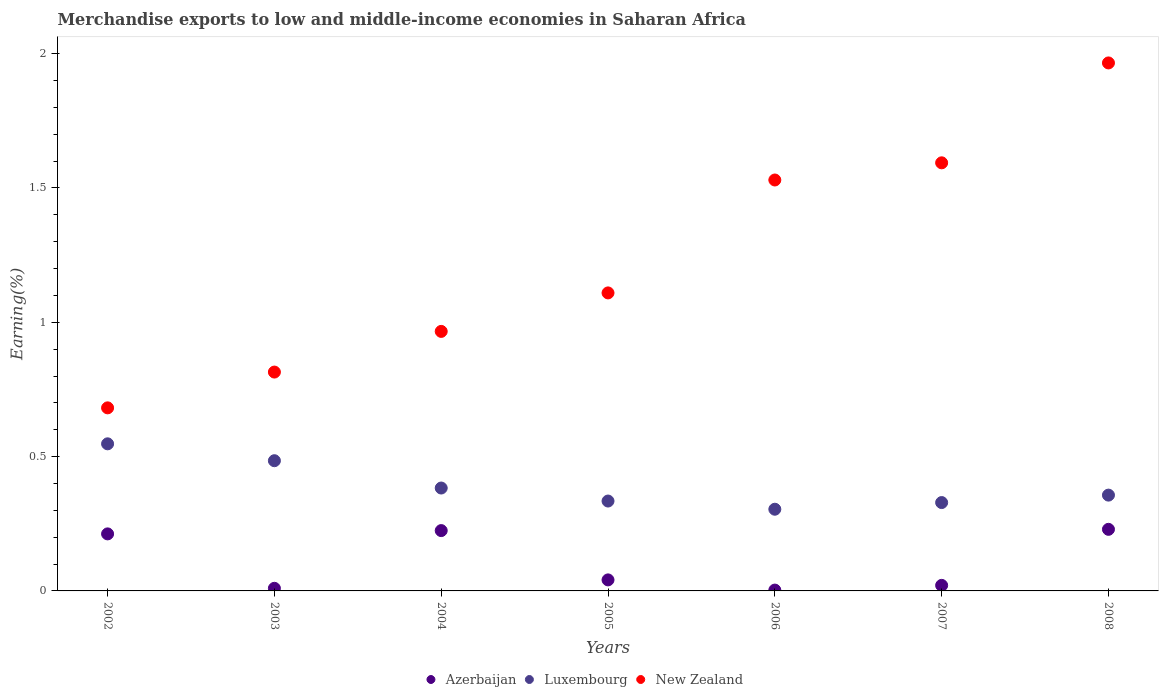How many different coloured dotlines are there?
Provide a succinct answer. 3. Is the number of dotlines equal to the number of legend labels?
Make the answer very short. Yes. What is the percentage of amount earned from merchandise exports in New Zealand in 2008?
Keep it short and to the point. 1.97. Across all years, what is the maximum percentage of amount earned from merchandise exports in New Zealand?
Your answer should be very brief. 1.97. Across all years, what is the minimum percentage of amount earned from merchandise exports in New Zealand?
Offer a terse response. 0.68. In which year was the percentage of amount earned from merchandise exports in Azerbaijan minimum?
Keep it short and to the point. 2006. What is the total percentage of amount earned from merchandise exports in Luxembourg in the graph?
Provide a succinct answer. 2.74. What is the difference between the percentage of amount earned from merchandise exports in New Zealand in 2004 and that in 2007?
Offer a terse response. -0.63. What is the difference between the percentage of amount earned from merchandise exports in Azerbaijan in 2006 and the percentage of amount earned from merchandise exports in New Zealand in 2004?
Your answer should be very brief. -0.96. What is the average percentage of amount earned from merchandise exports in New Zealand per year?
Make the answer very short. 1.24. In the year 2002, what is the difference between the percentage of amount earned from merchandise exports in Luxembourg and percentage of amount earned from merchandise exports in Azerbaijan?
Your response must be concise. 0.34. What is the ratio of the percentage of amount earned from merchandise exports in New Zealand in 2004 to that in 2007?
Your answer should be very brief. 0.61. Is the percentage of amount earned from merchandise exports in Luxembourg in 2004 less than that in 2008?
Provide a short and direct response. No. What is the difference between the highest and the second highest percentage of amount earned from merchandise exports in New Zealand?
Provide a succinct answer. 0.37. What is the difference between the highest and the lowest percentage of amount earned from merchandise exports in Azerbaijan?
Your answer should be very brief. 0.23. Is it the case that in every year, the sum of the percentage of amount earned from merchandise exports in New Zealand and percentage of amount earned from merchandise exports in Luxembourg  is greater than the percentage of amount earned from merchandise exports in Azerbaijan?
Ensure brevity in your answer.  Yes. Is the percentage of amount earned from merchandise exports in New Zealand strictly less than the percentage of amount earned from merchandise exports in Azerbaijan over the years?
Give a very brief answer. No. How many years are there in the graph?
Your answer should be compact. 7. What is the difference between two consecutive major ticks on the Y-axis?
Your response must be concise. 0.5. Are the values on the major ticks of Y-axis written in scientific E-notation?
Ensure brevity in your answer.  No. Where does the legend appear in the graph?
Make the answer very short. Bottom center. How many legend labels are there?
Offer a very short reply. 3. How are the legend labels stacked?
Your answer should be compact. Horizontal. What is the title of the graph?
Your answer should be compact. Merchandise exports to low and middle-income economies in Saharan Africa. What is the label or title of the X-axis?
Your response must be concise. Years. What is the label or title of the Y-axis?
Your answer should be compact. Earning(%). What is the Earning(%) in Azerbaijan in 2002?
Your response must be concise. 0.21. What is the Earning(%) in Luxembourg in 2002?
Your response must be concise. 0.55. What is the Earning(%) of New Zealand in 2002?
Ensure brevity in your answer.  0.68. What is the Earning(%) of Azerbaijan in 2003?
Ensure brevity in your answer.  0.01. What is the Earning(%) of Luxembourg in 2003?
Provide a short and direct response. 0.48. What is the Earning(%) of New Zealand in 2003?
Make the answer very short. 0.81. What is the Earning(%) in Azerbaijan in 2004?
Make the answer very short. 0.22. What is the Earning(%) of Luxembourg in 2004?
Provide a short and direct response. 0.38. What is the Earning(%) of New Zealand in 2004?
Your answer should be compact. 0.97. What is the Earning(%) of Azerbaijan in 2005?
Give a very brief answer. 0.04. What is the Earning(%) in Luxembourg in 2005?
Offer a very short reply. 0.33. What is the Earning(%) of New Zealand in 2005?
Give a very brief answer. 1.11. What is the Earning(%) in Azerbaijan in 2006?
Your answer should be very brief. 0. What is the Earning(%) in Luxembourg in 2006?
Offer a very short reply. 0.3. What is the Earning(%) of New Zealand in 2006?
Your answer should be compact. 1.53. What is the Earning(%) of Azerbaijan in 2007?
Offer a very short reply. 0.02. What is the Earning(%) of Luxembourg in 2007?
Keep it short and to the point. 0.33. What is the Earning(%) of New Zealand in 2007?
Give a very brief answer. 1.59. What is the Earning(%) of Azerbaijan in 2008?
Your answer should be compact. 0.23. What is the Earning(%) in Luxembourg in 2008?
Keep it short and to the point. 0.36. What is the Earning(%) in New Zealand in 2008?
Provide a short and direct response. 1.97. Across all years, what is the maximum Earning(%) of Azerbaijan?
Offer a terse response. 0.23. Across all years, what is the maximum Earning(%) of Luxembourg?
Your answer should be compact. 0.55. Across all years, what is the maximum Earning(%) in New Zealand?
Provide a short and direct response. 1.97. Across all years, what is the minimum Earning(%) in Azerbaijan?
Keep it short and to the point. 0. Across all years, what is the minimum Earning(%) in Luxembourg?
Keep it short and to the point. 0.3. Across all years, what is the minimum Earning(%) in New Zealand?
Give a very brief answer. 0.68. What is the total Earning(%) in Azerbaijan in the graph?
Ensure brevity in your answer.  0.74. What is the total Earning(%) of Luxembourg in the graph?
Your answer should be very brief. 2.74. What is the total Earning(%) of New Zealand in the graph?
Offer a very short reply. 8.66. What is the difference between the Earning(%) in Azerbaijan in 2002 and that in 2003?
Provide a short and direct response. 0.2. What is the difference between the Earning(%) in Luxembourg in 2002 and that in 2003?
Your response must be concise. 0.06. What is the difference between the Earning(%) of New Zealand in 2002 and that in 2003?
Provide a short and direct response. -0.13. What is the difference between the Earning(%) of Azerbaijan in 2002 and that in 2004?
Your response must be concise. -0.01. What is the difference between the Earning(%) of Luxembourg in 2002 and that in 2004?
Your response must be concise. 0.16. What is the difference between the Earning(%) in New Zealand in 2002 and that in 2004?
Your response must be concise. -0.28. What is the difference between the Earning(%) in Azerbaijan in 2002 and that in 2005?
Provide a short and direct response. 0.17. What is the difference between the Earning(%) in Luxembourg in 2002 and that in 2005?
Your response must be concise. 0.21. What is the difference between the Earning(%) in New Zealand in 2002 and that in 2005?
Ensure brevity in your answer.  -0.43. What is the difference between the Earning(%) of Azerbaijan in 2002 and that in 2006?
Provide a short and direct response. 0.21. What is the difference between the Earning(%) in Luxembourg in 2002 and that in 2006?
Your answer should be very brief. 0.24. What is the difference between the Earning(%) in New Zealand in 2002 and that in 2006?
Make the answer very short. -0.85. What is the difference between the Earning(%) of Azerbaijan in 2002 and that in 2007?
Keep it short and to the point. 0.19. What is the difference between the Earning(%) in Luxembourg in 2002 and that in 2007?
Your response must be concise. 0.22. What is the difference between the Earning(%) of New Zealand in 2002 and that in 2007?
Provide a short and direct response. -0.91. What is the difference between the Earning(%) in Azerbaijan in 2002 and that in 2008?
Offer a very short reply. -0.02. What is the difference between the Earning(%) of Luxembourg in 2002 and that in 2008?
Offer a terse response. 0.19. What is the difference between the Earning(%) of New Zealand in 2002 and that in 2008?
Your answer should be compact. -1.28. What is the difference between the Earning(%) of Azerbaijan in 2003 and that in 2004?
Your answer should be very brief. -0.21. What is the difference between the Earning(%) of Luxembourg in 2003 and that in 2004?
Your response must be concise. 0.1. What is the difference between the Earning(%) in New Zealand in 2003 and that in 2004?
Your answer should be compact. -0.15. What is the difference between the Earning(%) of Azerbaijan in 2003 and that in 2005?
Your response must be concise. -0.03. What is the difference between the Earning(%) in Luxembourg in 2003 and that in 2005?
Provide a short and direct response. 0.15. What is the difference between the Earning(%) in New Zealand in 2003 and that in 2005?
Your answer should be very brief. -0.29. What is the difference between the Earning(%) of Azerbaijan in 2003 and that in 2006?
Offer a terse response. 0.01. What is the difference between the Earning(%) in Luxembourg in 2003 and that in 2006?
Ensure brevity in your answer.  0.18. What is the difference between the Earning(%) of New Zealand in 2003 and that in 2006?
Provide a succinct answer. -0.71. What is the difference between the Earning(%) of Azerbaijan in 2003 and that in 2007?
Ensure brevity in your answer.  -0.01. What is the difference between the Earning(%) of Luxembourg in 2003 and that in 2007?
Offer a very short reply. 0.16. What is the difference between the Earning(%) in New Zealand in 2003 and that in 2007?
Make the answer very short. -0.78. What is the difference between the Earning(%) of Azerbaijan in 2003 and that in 2008?
Provide a succinct answer. -0.22. What is the difference between the Earning(%) in Luxembourg in 2003 and that in 2008?
Provide a short and direct response. 0.13. What is the difference between the Earning(%) of New Zealand in 2003 and that in 2008?
Provide a succinct answer. -1.15. What is the difference between the Earning(%) in Azerbaijan in 2004 and that in 2005?
Give a very brief answer. 0.18. What is the difference between the Earning(%) in Luxembourg in 2004 and that in 2005?
Offer a terse response. 0.05. What is the difference between the Earning(%) of New Zealand in 2004 and that in 2005?
Ensure brevity in your answer.  -0.14. What is the difference between the Earning(%) in Azerbaijan in 2004 and that in 2006?
Ensure brevity in your answer.  0.22. What is the difference between the Earning(%) in Luxembourg in 2004 and that in 2006?
Your response must be concise. 0.08. What is the difference between the Earning(%) of New Zealand in 2004 and that in 2006?
Give a very brief answer. -0.56. What is the difference between the Earning(%) of Azerbaijan in 2004 and that in 2007?
Your response must be concise. 0.2. What is the difference between the Earning(%) in Luxembourg in 2004 and that in 2007?
Provide a succinct answer. 0.05. What is the difference between the Earning(%) of New Zealand in 2004 and that in 2007?
Provide a short and direct response. -0.63. What is the difference between the Earning(%) in Azerbaijan in 2004 and that in 2008?
Make the answer very short. -0. What is the difference between the Earning(%) in Luxembourg in 2004 and that in 2008?
Your answer should be compact. 0.03. What is the difference between the Earning(%) in New Zealand in 2004 and that in 2008?
Provide a short and direct response. -1. What is the difference between the Earning(%) of Azerbaijan in 2005 and that in 2006?
Ensure brevity in your answer.  0.04. What is the difference between the Earning(%) in Luxembourg in 2005 and that in 2006?
Keep it short and to the point. 0.03. What is the difference between the Earning(%) in New Zealand in 2005 and that in 2006?
Provide a short and direct response. -0.42. What is the difference between the Earning(%) in Azerbaijan in 2005 and that in 2007?
Offer a very short reply. 0.02. What is the difference between the Earning(%) of Luxembourg in 2005 and that in 2007?
Provide a succinct answer. 0.01. What is the difference between the Earning(%) in New Zealand in 2005 and that in 2007?
Your response must be concise. -0.48. What is the difference between the Earning(%) in Azerbaijan in 2005 and that in 2008?
Provide a succinct answer. -0.19. What is the difference between the Earning(%) of Luxembourg in 2005 and that in 2008?
Your answer should be very brief. -0.02. What is the difference between the Earning(%) in New Zealand in 2005 and that in 2008?
Provide a succinct answer. -0.86. What is the difference between the Earning(%) of Azerbaijan in 2006 and that in 2007?
Provide a succinct answer. -0.02. What is the difference between the Earning(%) of Luxembourg in 2006 and that in 2007?
Ensure brevity in your answer.  -0.02. What is the difference between the Earning(%) in New Zealand in 2006 and that in 2007?
Ensure brevity in your answer.  -0.06. What is the difference between the Earning(%) in Azerbaijan in 2006 and that in 2008?
Keep it short and to the point. -0.23. What is the difference between the Earning(%) in Luxembourg in 2006 and that in 2008?
Keep it short and to the point. -0.05. What is the difference between the Earning(%) in New Zealand in 2006 and that in 2008?
Make the answer very short. -0.44. What is the difference between the Earning(%) in Azerbaijan in 2007 and that in 2008?
Your answer should be very brief. -0.21. What is the difference between the Earning(%) in Luxembourg in 2007 and that in 2008?
Provide a succinct answer. -0.03. What is the difference between the Earning(%) in New Zealand in 2007 and that in 2008?
Your answer should be very brief. -0.37. What is the difference between the Earning(%) of Azerbaijan in 2002 and the Earning(%) of Luxembourg in 2003?
Make the answer very short. -0.27. What is the difference between the Earning(%) of Azerbaijan in 2002 and the Earning(%) of New Zealand in 2003?
Make the answer very short. -0.6. What is the difference between the Earning(%) of Luxembourg in 2002 and the Earning(%) of New Zealand in 2003?
Ensure brevity in your answer.  -0.27. What is the difference between the Earning(%) of Azerbaijan in 2002 and the Earning(%) of Luxembourg in 2004?
Provide a short and direct response. -0.17. What is the difference between the Earning(%) in Azerbaijan in 2002 and the Earning(%) in New Zealand in 2004?
Ensure brevity in your answer.  -0.75. What is the difference between the Earning(%) in Luxembourg in 2002 and the Earning(%) in New Zealand in 2004?
Provide a short and direct response. -0.42. What is the difference between the Earning(%) in Azerbaijan in 2002 and the Earning(%) in Luxembourg in 2005?
Keep it short and to the point. -0.12. What is the difference between the Earning(%) in Azerbaijan in 2002 and the Earning(%) in New Zealand in 2005?
Provide a succinct answer. -0.9. What is the difference between the Earning(%) in Luxembourg in 2002 and the Earning(%) in New Zealand in 2005?
Offer a very short reply. -0.56. What is the difference between the Earning(%) of Azerbaijan in 2002 and the Earning(%) of Luxembourg in 2006?
Offer a terse response. -0.09. What is the difference between the Earning(%) in Azerbaijan in 2002 and the Earning(%) in New Zealand in 2006?
Offer a terse response. -1.32. What is the difference between the Earning(%) in Luxembourg in 2002 and the Earning(%) in New Zealand in 2006?
Ensure brevity in your answer.  -0.98. What is the difference between the Earning(%) of Azerbaijan in 2002 and the Earning(%) of Luxembourg in 2007?
Offer a terse response. -0.12. What is the difference between the Earning(%) in Azerbaijan in 2002 and the Earning(%) in New Zealand in 2007?
Keep it short and to the point. -1.38. What is the difference between the Earning(%) of Luxembourg in 2002 and the Earning(%) of New Zealand in 2007?
Provide a succinct answer. -1.05. What is the difference between the Earning(%) of Azerbaijan in 2002 and the Earning(%) of Luxembourg in 2008?
Ensure brevity in your answer.  -0.14. What is the difference between the Earning(%) in Azerbaijan in 2002 and the Earning(%) in New Zealand in 2008?
Provide a short and direct response. -1.75. What is the difference between the Earning(%) in Luxembourg in 2002 and the Earning(%) in New Zealand in 2008?
Ensure brevity in your answer.  -1.42. What is the difference between the Earning(%) of Azerbaijan in 2003 and the Earning(%) of Luxembourg in 2004?
Provide a short and direct response. -0.37. What is the difference between the Earning(%) of Azerbaijan in 2003 and the Earning(%) of New Zealand in 2004?
Provide a short and direct response. -0.96. What is the difference between the Earning(%) of Luxembourg in 2003 and the Earning(%) of New Zealand in 2004?
Provide a succinct answer. -0.48. What is the difference between the Earning(%) of Azerbaijan in 2003 and the Earning(%) of Luxembourg in 2005?
Offer a terse response. -0.32. What is the difference between the Earning(%) of Azerbaijan in 2003 and the Earning(%) of New Zealand in 2005?
Ensure brevity in your answer.  -1.1. What is the difference between the Earning(%) in Luxembourg in 2003 and the Earning(%) in New Zealand in 2005?
Provide a succinct answer. -0.62. What is the difference between the Earning(%) in Azerbaijan in 2003 and the Earning(%) in Luxembourg in 2006?
Your answer should be very brief. -0.29. What is the difference between the Earning(%) in Azerbaijan in 2003 and the Earning(%) in New Zealand in 2006?
Your answer should be very brief. -1.52. What is the difference between the Earning(%) of Luxembourg in 2003 and the Earning(%) of New Zealand in 2006?
Offer a terse response. -1.04. What is the difference between the Earning(%) of Azerbaijan in 2003 and the Earning(%) of Luxembourg in 2007?
Offer a very short reply. -0.32. What is the difference between the Earning(%) in Azerbaijan in 2003 and the Earning(%) in New Zealand in 2007?
Your response must be concise. -1.58. What is the difference between the Earning(%) in Luxembourg in 2003 and the Earning(%) in New Zealand in 2007?
Make the answer very short. -1.11. What is the difference between the Earning(%) in Azerbaijan in 2003 and the Earning(%) in Luxembourg in 2008?
Ensure brevity in your answer.  -0.35. What is the difference between the Earning(%) of Azerbaijan in 2003 and the Earning(%) of New Zealand in 2008?
Offer a very short reply. -1.96. What is the difference between the Earning(%) of Luxembourg in 2003 and the Earning(%) of New Zealand in 2008?
Offer a very short reply. -1.48. What is the difference between the Earning(%) in Azerbaijan in 2004 and the Earning(%) in Luxembourg in 2005?
Your response must be concise. -0.11. What is the difference between the Earning(%) in Azerbaijan in 2004 and the Earning(%) in New Zealand in 2005?
Ensure brevity in your answer.  -0.88. What is the difference between the Earning(%) in Luxembourg in 2004 and the Earning(%) in New Zealand in 2005?
Your answer should be very brief. -0.73. What is the difference between the Earning(%) of Azerbaijan in 2004 and the Earning(%) of Luxembourg in 2006?
Ensure brevity in your answer.  -0.08. What is the difference between the Earning(%) in Azerbaijan in 2004 and the Earning(%) in New Zealand in 2006?
Offer a very short reply. -1.31. What is the difference between the Earning(%) of Luxembourg in 2004 and the Earning(%) of New Zealand in 2006?
Your answer should be very brief. -1.15. What is the difference between the Earning(%) in Azerbaijan in 2004 and the Earning(%) in Luxembourg in 2007?
Your response must be concise. -0.1. What is the difference between the Earning(%) of Azerbaijan in 2004 and the Earning(%) of New Zealand in 2007?
Your answer should be compact. -1.37. What is the difference between the Earning(%) in Luxembourg in 2004 and the Earning(%) in New Zealand in 2007?
Make the answer very short. -1.21. What is the difference between the Earning(%) of Azerbaijan in 2004 and the Earning(%) of Luxembourg in 2008?
Provide a succinct answer. -0.13. What is the difference between the Earning(%) in Azerbaijan in 2004 and the Earning(%) in New Zealand in 2008?
Your response must be concise. -1.74. What is the difference between the Earning(%) of Luxembourg in 2004 and the Earning(%) of New Zealand in 2008?
Offer a very short reply. -1.58. What is the difference between the Earning(%) in Azerbaijan in 2005 and the Earning(%) in Luxembourg in 2006?
Make the answer very short. -0.26. What is the difference between the Earning(%) in Azerbaijan in 2005 and the Earning(%) in New Zealand in 2006?
Make the answer very short. -1.49. What is the difference between the Earning(%) of Luxembourg in 2005 and the Earning(%) of New Zealand in 2006?
Provide a succinct answer. -1.2. What is the difference between the Earning(%) in Azerbaijan in 2005 and the Earning(%) in Luxembourg in 2007?
Offer a very short reply. -0.29. What is the difference between the Earning(%) of Azerbaijan in 2005 and the Earning(%) of New Zealand in 2007?
Offer a very short reply. -1.55. What is the difference between the Earning(%) of Luxembourg in 2005 and the Earning(%) of New Zealand in 2007?
Your answer should be very brief. -1.26. What is the difference between the Earning(%) of Azerbaijan in 2005 and the Earning(%) of Luxembourg in 2008?
Provide a short and direct response. -0.32. What is the difference between the Earning(%) of Azerbaijan in 2005 and the Earning(%) of New Zealand in 2008?
Make the answer very short. -1.92. What is the difference between the Earning(%) in Luxembourg in 2005 and the Earning(%) in New Zealand in 2008?
Keep it short and to the point. -1.63. What is the difference between the Earning(%) in Azerbaijan in 2006 and the Earning(%) in Luxembourg in 2007?
Your answer should be very brief. -0.33. What is the difference between the Earning(%) in Azerbaijan in 2006 and the Earning(%) in New Zealand in 2007?
Make the answer very short. -1.59. What is the difference between the Earning(%) of Luxembourg in 2006 and the Earning(%) of New Zealand in 2007?
Offer a very short reply. -1.29. What is the difference between the Earning(%) of Azerbaijan in 2006 and the Earning(%) of Luxembourg in 2008?
Ensure brevity in your answer.  -0.35. What is the difference between the Earning(%) in Azerbaijan in 2006 and the Earning(%) in New Zealand in 2008?
Your response must be concise. -1.96. What is the difference between the Earning(%) in Luxembourg in 2006 and the Earning(%) in New Zealand in 2008?
Offer a terse response. -1.66. What is the difference between the Earning(%) in Azerbaijan in 2007 and the Earning(%) in Luxembourg in 2008?
Ensure brevity in your answer.  -0.34. What is the difference between the Earning(%) of Azerbaijan in 2007 and the Earning(%) of New Zealand in 2008?
Give a very brief answer. -1.94. What is the difference between the Earning(%) in Luxembourg in 2007 and the Earning(%) in New Zealand in 2008?
Keep it short and to the point. -1.64. What is the average Earning(%) of Azerbaijan per year?
Your answer should be compact. 0.11. What is the average Earning(%) of Luxembourg per year?
Offer a terse response. 0.39. What is the average Earning(%) of New Zealand per year?
Offer a very short reply. 1.24. In the year 2002, what is the difference between the Earning(%) in Azerbaijan and Earning(%) in Luxembourg?
Keep it short and to the point. -0.34. In the year 2002, what is the difference between the Earning(%) of Azerbaijan and Earning(%) of New Zealand?
Your answer should be very brief. -0.47. In the year 2002, what is the difference between the Earning(%) of Luxembourg and Earning(%) of New Zealand?
Offer a terse response. -0.13. In the year 2003, what is the difference between the Earning(%) in Azerbaijan and Earning(%) in Luxembourg?
Your response must be concise. -0.47. In the year 2003, what is the difference between the Earning(%) of Azerbaijan and Earning(%) of New Zealand?
Your response must be concise. -0.81. In the year 2003, what is the difference between the Earning(%) of Luxembourg and Earning(%) of New Zealand?
Your answer should be very brief. -0.33. In the year 2004, what is the difference between the Earning(%) in Azerbaijan and Earning(%) in Luxembourg?
Your response must be concise. -0.16. In the year 2004, what is the difference between the Earning(%) in Azerbaijan and Earning(%) in New Zealand?
Ensure brevity in your answer.  -0.74. In the year 2004, what is the difference between the Earning(%) of Luxembourg and Earning(%) of New Zealand?
Your answer should be very brief. -0.58. In the year 2005, what is the difference between the Earning(%) of Azerbaijan and Earning(%) of Luxembourg?
Offer a terse response. -0.29. In the year 2005, what is the difference between the Earning(%) of Azerbaijan and Earning(%) of New Zealand?
Make the answer very short. -1.07. In the year 2005, what is the difference between the Earning(%) in Luxembourg and Earning(%) in New Zealand?
Offer a very short reply. -0.77. In the year 2006, what is the difference between the Earning(%) in Azerbaijan and Earning(%) in Luxembourg?
Your answer should be very brief. -0.3. In the year 2006, what is the difference between the Earning(%) in Azerbaijan and Earning(%) in New Zealand?
Offer a terse response. -1.53. In the year 2006, what is the difference between the Earning(%) in Luxembourg and Earning(%) in New Zealand?
Ensure brevity in your answer.  -1.23. In the year 2007, what is the difference between the Earning(%) of Azerbaijan and Earning(%) of Luxembourg?
Give a very brief answer. -0.31. In the year 2007, what is the difference between the Earning(%) of Azerbaijan and Earning(%) of New Zealand?
Your response must be concise. -1.57. In the year 2007, what is the difference between the Earning(%) of Luxembourg and Earning(%) of New Zealand?
Your response must be concise. -1.26. In the year 2008, what is the difference between the Earning(%) in Azerbaijan and Earning(%) in Luxembourg?
Make the answer very short. -0.13. In the year 2008, what is the difference between the Earning(%) in Azerbaijan and Earning(%) in New Zealand?
Make the answer very short. -1.74. In the year 2008, what is the difference between the Earning(%) in Luxembourg and Earning(%) in New Zealand?
Your answer should be very brief. -1.61. What is the ratio of the Earning(%) in Azerbaijan in 2002 to that in 2003?
Your response must be concise. 21.8. What is the ratio of the Earning(%) in Luxembourg in 2002 to that in 2003?
Keep it short and to the point. 1.13. What is the ratio of the Earning(%) in New Zealand in 2002 to that in 2003?
Your response must be concise. 0.84. What is the ratio of the Earning(%) in Azerbaijan in 2002 to that in 2004?
Your answer should be very brief. 0.95. What is the ratio of the Earning(%) of Luxembourg in 2002 to that in 2004?
Your answer should be very brief. 1.43. What is the ratio of the Earning(%) in New Zealand in 2002 to that in 2004?
Offer a terse response. 0.71. What is the ratio of the Earning(%) in Azerbaijan in 2002 to that in 2005?
Your answer should be compact. 5.17. What is the ratio of the Earning(%) of Luxembourg in 2002 to that in 2005?
Offer a very short reply. 1.64. What is the ratio of the Earning(%) of New Zealand in 2002 to that in 2005?
Your answer should be very brief. 0.61. What is the ratio of the Earning(%) in Azerbaijan in 2002 to that in 2006?
Give a very brief answer. 67.75. What is the ratio of the Earning(%) in Luxembourg in 2002 to that in 2006?
Your answer should be very brief. 1.8. What is the ratio of the Earning(%) in New Zealand in 2002 to that in 2006?
Your response must be concise. 0.45. What is the ratio of the Earning(%) of Azerbaijan in 2002 to that in 2007?
Your response must be concise. 10.29. What is the ratio of the Earning(%) in Luxembourg in 2002 to that in 2007?
Keep it short and to the point. 1.66. What is the ratio of the Earning(%) in New Zealand in 2002 to that in 2007?
Provide a succinct answer. 0.43. What is the ratio of the Earning(%) in Azerbaijan in 2002 to that in 2008?
Offer a very short reply. 0.93. What is the ratio of the Earning(%) in Luxembourg in 2002 to that in 2008?
Make the answer very short. 1.54. What is the ratio of the Earning(%) in New Zealand in 2002 to that in 2008?
Keep it short and to the point. 0.35. What is the ratio of the Earning(%) in Azerbaijan in 2003 to that in 2004?
Your answer should be very brief. 0.04. What is the ratio of the Earning(%) in Luxembourg in 2003 to that in 2004?
Keep it short and to the point. 1.27. What is the ratio of the Earning(%) in New Zealand in 2003 to that in 2004?
Your answer should be compact. 0.84. What is the ratio of the Earning(%) in Azerbaijan in 2003 to that in 2005?
Keep it short and to the point. 0.24. What is the ratio of the Earning(%) of Luxembourg in 2003 to that in 2005?
Your answer should be compact. 1.45. What is the ratio of the Earning(%) in New Zealand in 2003 to that in 2005?
Your answer should be compact. 0.73. What is the ratio of the Earning(%) of Azerbaijan in 2003 to that in 2006?
Offer a very short reply. 3.11. What is the ratio of the Earning(%) of Luxembourg in 2003 to that in 2006?
Give a very brief answer. 1.59. What is the ratio of the Earning(%) of New Zealand in 2003 to that in 2006?
Your response must be concise. 0.53. What is the ratio of the Earning(%) of Azerbaijan in 2003 to that in 2007?
Offer a very short reply. 0.47. What is the ratio of the Earning(%) of Luxembourg in 2003 to that in 2007?
Your response must be concise. 1.47. What is the ratio of the Earning(%) of New Zealand in 2003 to that in 2007?
Make the answer very short. 0.51. What is the ratio of the Earning(%) of Azerbaijan in 2003 to that in 2008?
Offer a very short reply. 0.04. What is the ratio of the Earning(%) of Luxembourg in 2003 to that in 2008?
Give a very brief answer. 1.36. What is the ratio of the Earning(%) of New Zealand in 2003 to that in 2008?
Your answer should be very brief. 0.41. What is the ratio of the Earning(%) in Azerbaijan in 2004 to that in 2005?
Provide a short and direct response. 5.47. What is the ratio of the Earning(%) of Luxembourg in 2004 to that in 2005?
Your answer should be very brief. 1.14. What is the ratio of the Earning(%) in New Zealand in 2004 to that in 2005?
Your response must be concise. 0.87. What is the ratio of the Earning(%) in Azerbaijan in 2004 to that in 2006?
Give a very brief answer. 71.66. What is the ratio of the Earning(%) of Luxembourg in 2004 to that in 2006?
Your answer should be compact. 1.26. What is the ratio of the Earning(%) of New Zealand in 2004 to that in 2006?
Your response must be concise. 0.63. What is the ratio of the Earning(%) in Azerbaijan in 2004 to that in 2007?
Provide a succinct answer. 10.88. What is the ratio of the Earning(%) of Luxembourg in 2004 to that in 2007?
Keep it short and to the point. 1.16. What is the ratio of the Earning(%) in New Zealand in 2004 to that in 2007?
Your answer should be compact. 0.61. What is the ratio of the Earning(%) of Azerbaijan in 2004 to that in 2008?
Your response must be concise. 0.98. What is the ratio of the Earning(%) in Luxembourg in 2004 to that in 2008?
Offer a very short reply. 1.07. What is the ratio of the Earning(%) in New Zealand in 2004 to that in 2008?
Your response must be concise. 0.49. What is the ratio of the Earning(%) of Azerbaijan in 2005 to that in 2006?
Offer a very short reply. 13.1. What is the ratio of the Earning(%) in Luxembourg in 2005 to that in 2006?
Make the answer very short. 1.1. What is the ratio of the Earning(%) of New Zealand in 2005 to that in 2006?
Your answer should be compact. 0.73. What is the ratio of the Earning(%) in Azerbaijan in 2005 to that in 2007?
Give a very brief answer. 1.99. What is the ratio of the Earning(%) of Luxembourg in 2005 to that in 2007?
Your response must be concise. 1.02. What is the ratio of the Earning(%) of New Zealand in 2005 to that in 2007?
Provide a short and direct response. 0.7. What is the ratio of the Earning(%) in Azerbaijan in 2005 to that in 2008?
Provide a short and direct response. 0.18. What is the ratio of the Earning(%) in Luxembourg in 2005 to that in 2008?
Your answer should be very brief. 0.94. What is the ratio of the Earning(%) of New Zealand in 2005 to that in 2008?
Make the answer very short. 0.56. What is the ratio of the Earning(%) in Azerbaijan in 2006 to that in 2007?
Your response must be concise. 0.15. What is the ratio of the Earning(%) in Luxembourg in 2006 to that in 2007?
Ensure brevity in your answer.  0.92. What is the ratio of the Earning(%) of New Zealand in 2006 to that in 2007?
Offer a terse response. 0.96. What is the ratio of the Earning(%) in Azerbaijan in 2006 to that in 2008?
Give a very brief answer. 0.01. What is the ratio of the Earning(%) in Luxembourg in 2006 to that in 2008?
Provide a short and direct response. 0.85. What is the ratio of the Earning(%) in New Zealand in 2006 to that in 2008?
Your answer should be compact. 0.78. What is the ratio of the Earning(%) of Azerbaijan in 2007 to that in 2008?
Keep it short and to the point. 0.09. What is the ratio of the Earning(%) of Luxembourg in 2007 to that in 2008?
Provide a succinct answer. 0.92. What is the ratio of the Earning(%) of New Zealand in 2007 to that in 2008?
Provide a short and direct response. 0.81. What is the difference between the highest and the second highest Earning(%) of Azerbaijan?
Your answer should be very brief. 0. What is the difference between the highest and the second highest Earning(%) in Luxembourg?
Ensure brevity in your answer.  0.06. What is the difference between the highest and the second highest Earning(%) in New Zealand?
Ensure brevity in your answer.  0.37. What is the difference between the highest and the lowest Earning(%) of Azerbaijan?
Your answer should be very brief. 0.23. What is the difference between the highest and the lowest Earning(%) of Luxembourg?
Make the answer very short. 0.24. What is the difference between the highest and the lowest Earning(%) of New Zealand?
Make the answer very short. 1.28. 